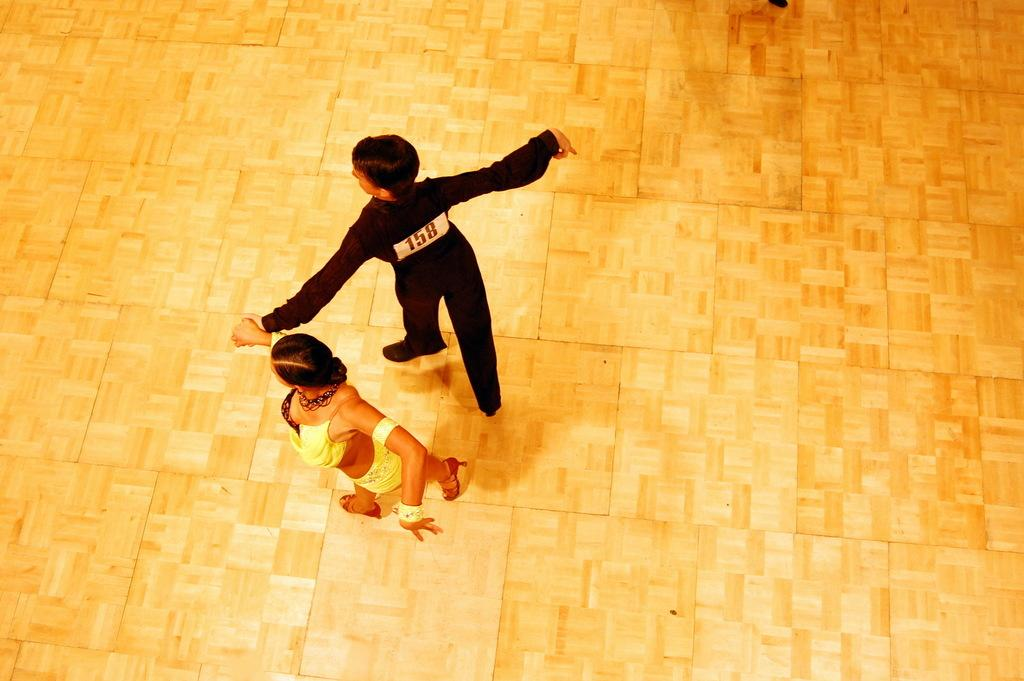How many people are in the image? There are two people in the image. What are the two people doing in the image? The two people are on the floor and holding hands. What type of guitar can be seen in the image? There is no guitar present in the image. How does the sleet affect the two people in the image? There is no mention of sleet in the image, so it cannot affect the two people. 